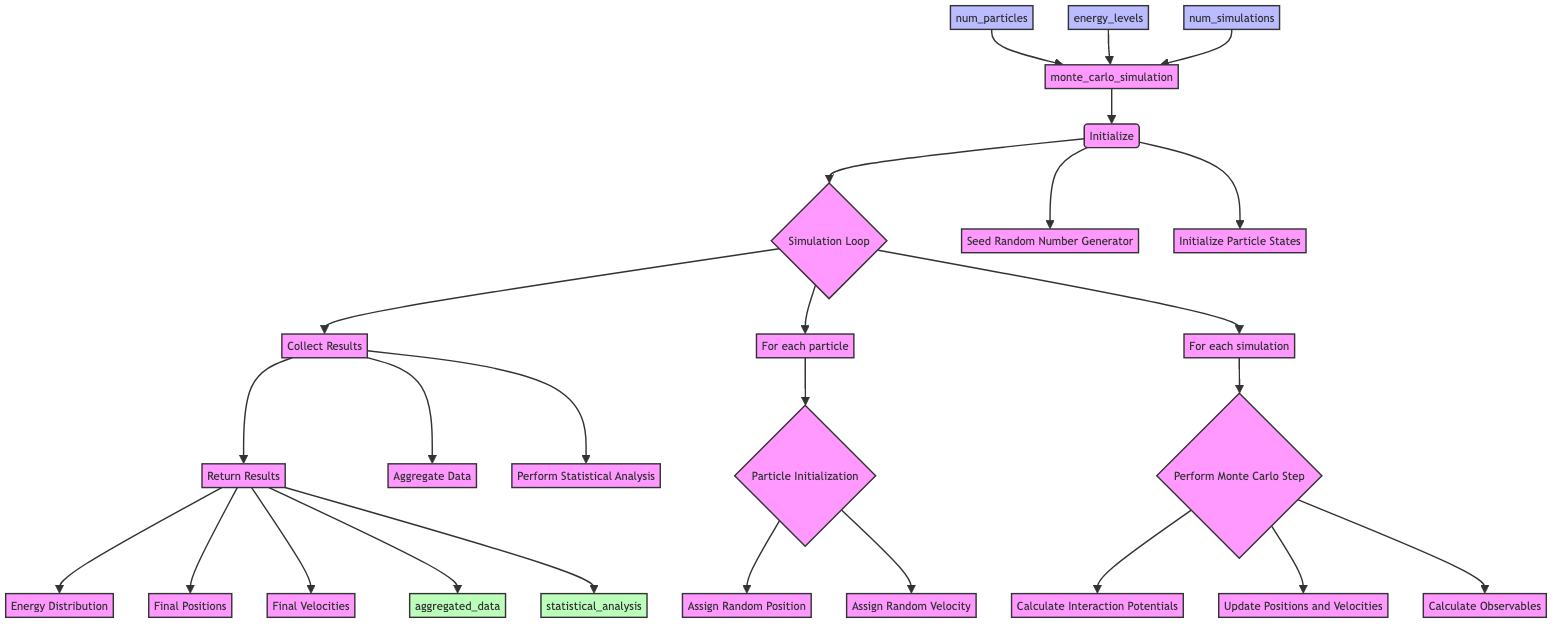what is the name of the main function in the flowchart? The name of the main function is shown at the start of the flowchart as "monte_carlo_simulation."
Answer: monte carlo simulation how many inputs does the function have? The function has three inputs indicated by three arrows leading to it from the input nodes.
Answer: 3 what is the first step in the flowchart? The first step listed in the flowchart after the function name is "Initialize."
Answer: Initialize what tasks are performed during the "Collect Results" step? The "Collect Results" step includes two tasks: "Aggregate Data" and "Perform Statistical Analysis."
Answer: Aggregate Data, Perform Statistical Analysis how many tasks are involved in the "Perform Monte Carlo Step"? In the "Perform Monte Carlo Step," there are three tasks: "Calculate Interaction Potentials," "Update Positions and Velocities," and "Calculate Observables."
Answer: 3 what is the output of the function? The outputs of the function are specified as results returned from "Return Results," which includes "Energy Distribution," "Final Positions," and "Final Velocities."
Answer: Energy Distribution, Final Positions, Final Velocities what is the relationship between "Simulation Loop" and "Collect Results"? "Simulation Loop" feeds directly into "Collect Results," indicating that after the simulation process is complete, results are collected next in the function's workflow.
Answer: Direct connection which step includes random position assignment? The step where random position assignment occurs is labeled "Particle Initialization" within the "Simulation Loop."
Answer: Particle Initialization what are the tasks involved in the "Initialize" step? In the "Initialize" step, two tasks are carried out: "Seed Random Number Generator" and "Initialize Particle States."
Answer: Seed Random Number Generator, Initialize Particle States 